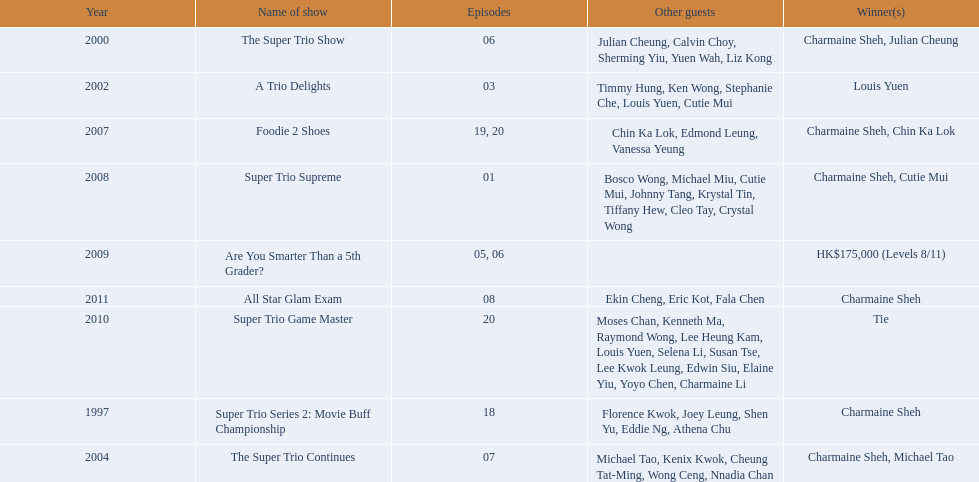What year was the only year were a tie occurred? 2010. 